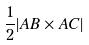<formula> <loc_0><loc_0><loc_500><loc_500>\frac { 1 } { 2 } | A B \times A C |</formula> 